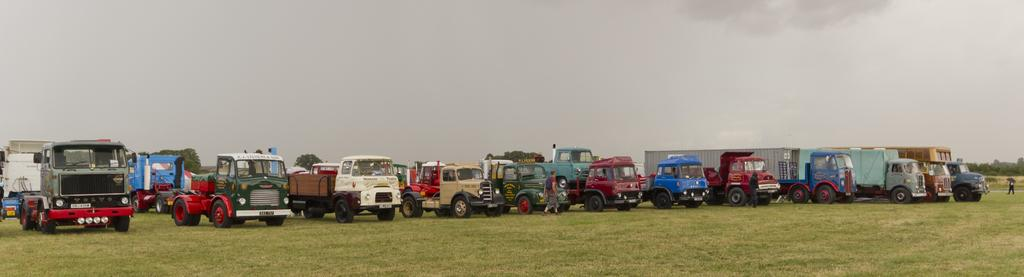What type of vehicles can be seen on the grassy land in the image? There are vehicles on the grassy land in the image. Where are the vehicles located in relation to the image? The vehicles are at the bottom of the image. What can be seen in the background of the image? There are trees in the background of the image. What is visible at the top of the image? The sky is visible at the top of the image. What type of stocking is hanging from the trees in the image? There are no stockings hanging from the trees in the image; only vehicles, grassy land, trees, and the sky are present. 